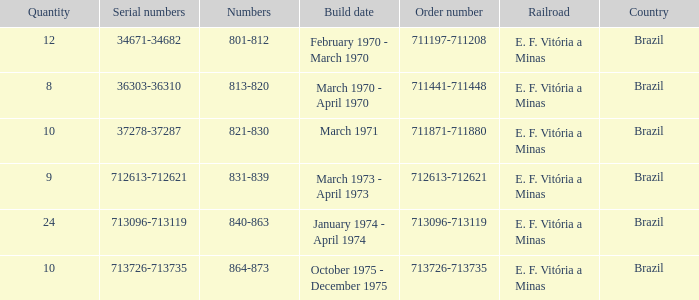What country has the order number 711871-711880? Brazil. 